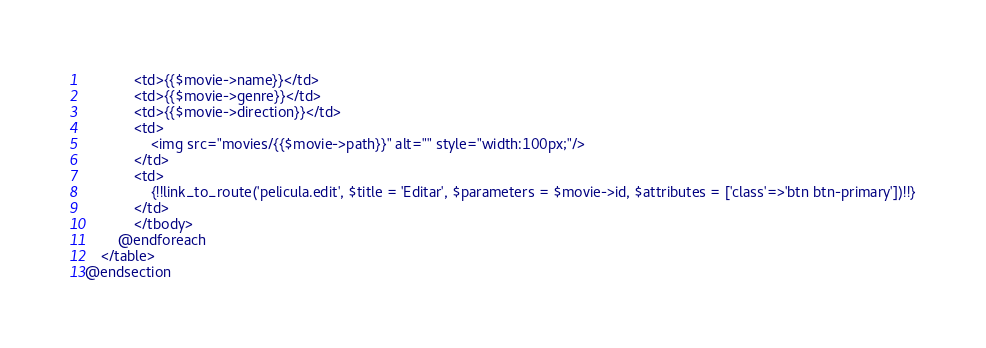Convert code to text. <code><loc_0><loc_0><loc_500><loc_500><_PHP_>            <td>{{$movie->name}}</td>
            <td>{{$movie->genre}}</td>
            <td>{{$movie->direction}}</td>
            <td>
                <img src="movies/{{$movie->path}}" alt="" style="width:100px;"/>
            </td>
            <td>
                {!!link_to_route('pelicula.edit', $title = 'Editar', $parameters = $movie->id, $attributes = ['class'=>'btn btn-primary'])!!}
            </td>
            </tbody>
        @endforeach
    </table>
@endsection</code> 